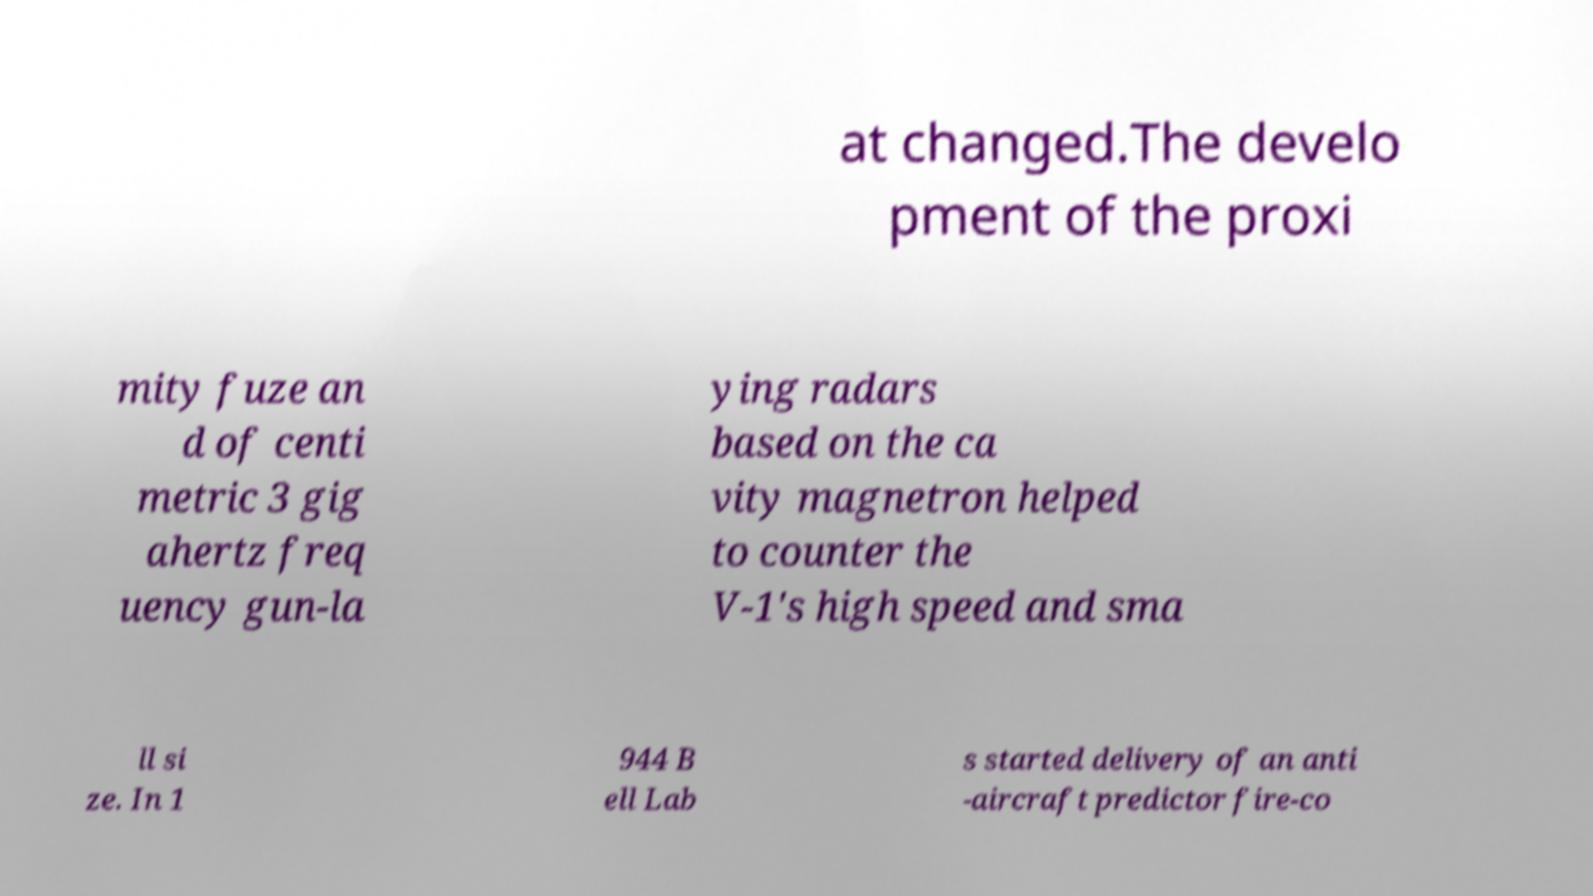I need the written content from this picture converted into text. Can you do that? at changed.The develo pment of the proxi mity fuze an d of centi metric 3 gig ahertz freq uency gun-la ying radars based on the ca vity magnetron helped to counter the V-1's high speed and sma ll si ze. In 1 944 B ell Lab s started delivery of an anti -aircraft predictor fire-co 